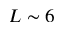Convert formula to latex. <formula><loc_0><loc_0><loc_500><loc_500>L \sim 6</formula> 